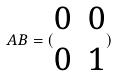Convert formula to latex. <formula><loc_0><loc_0><loc_500><loc_500>A B = ( \begin{matrix} 0 & 0 \\ 0 & 1 \end{matrix} )</formula> 